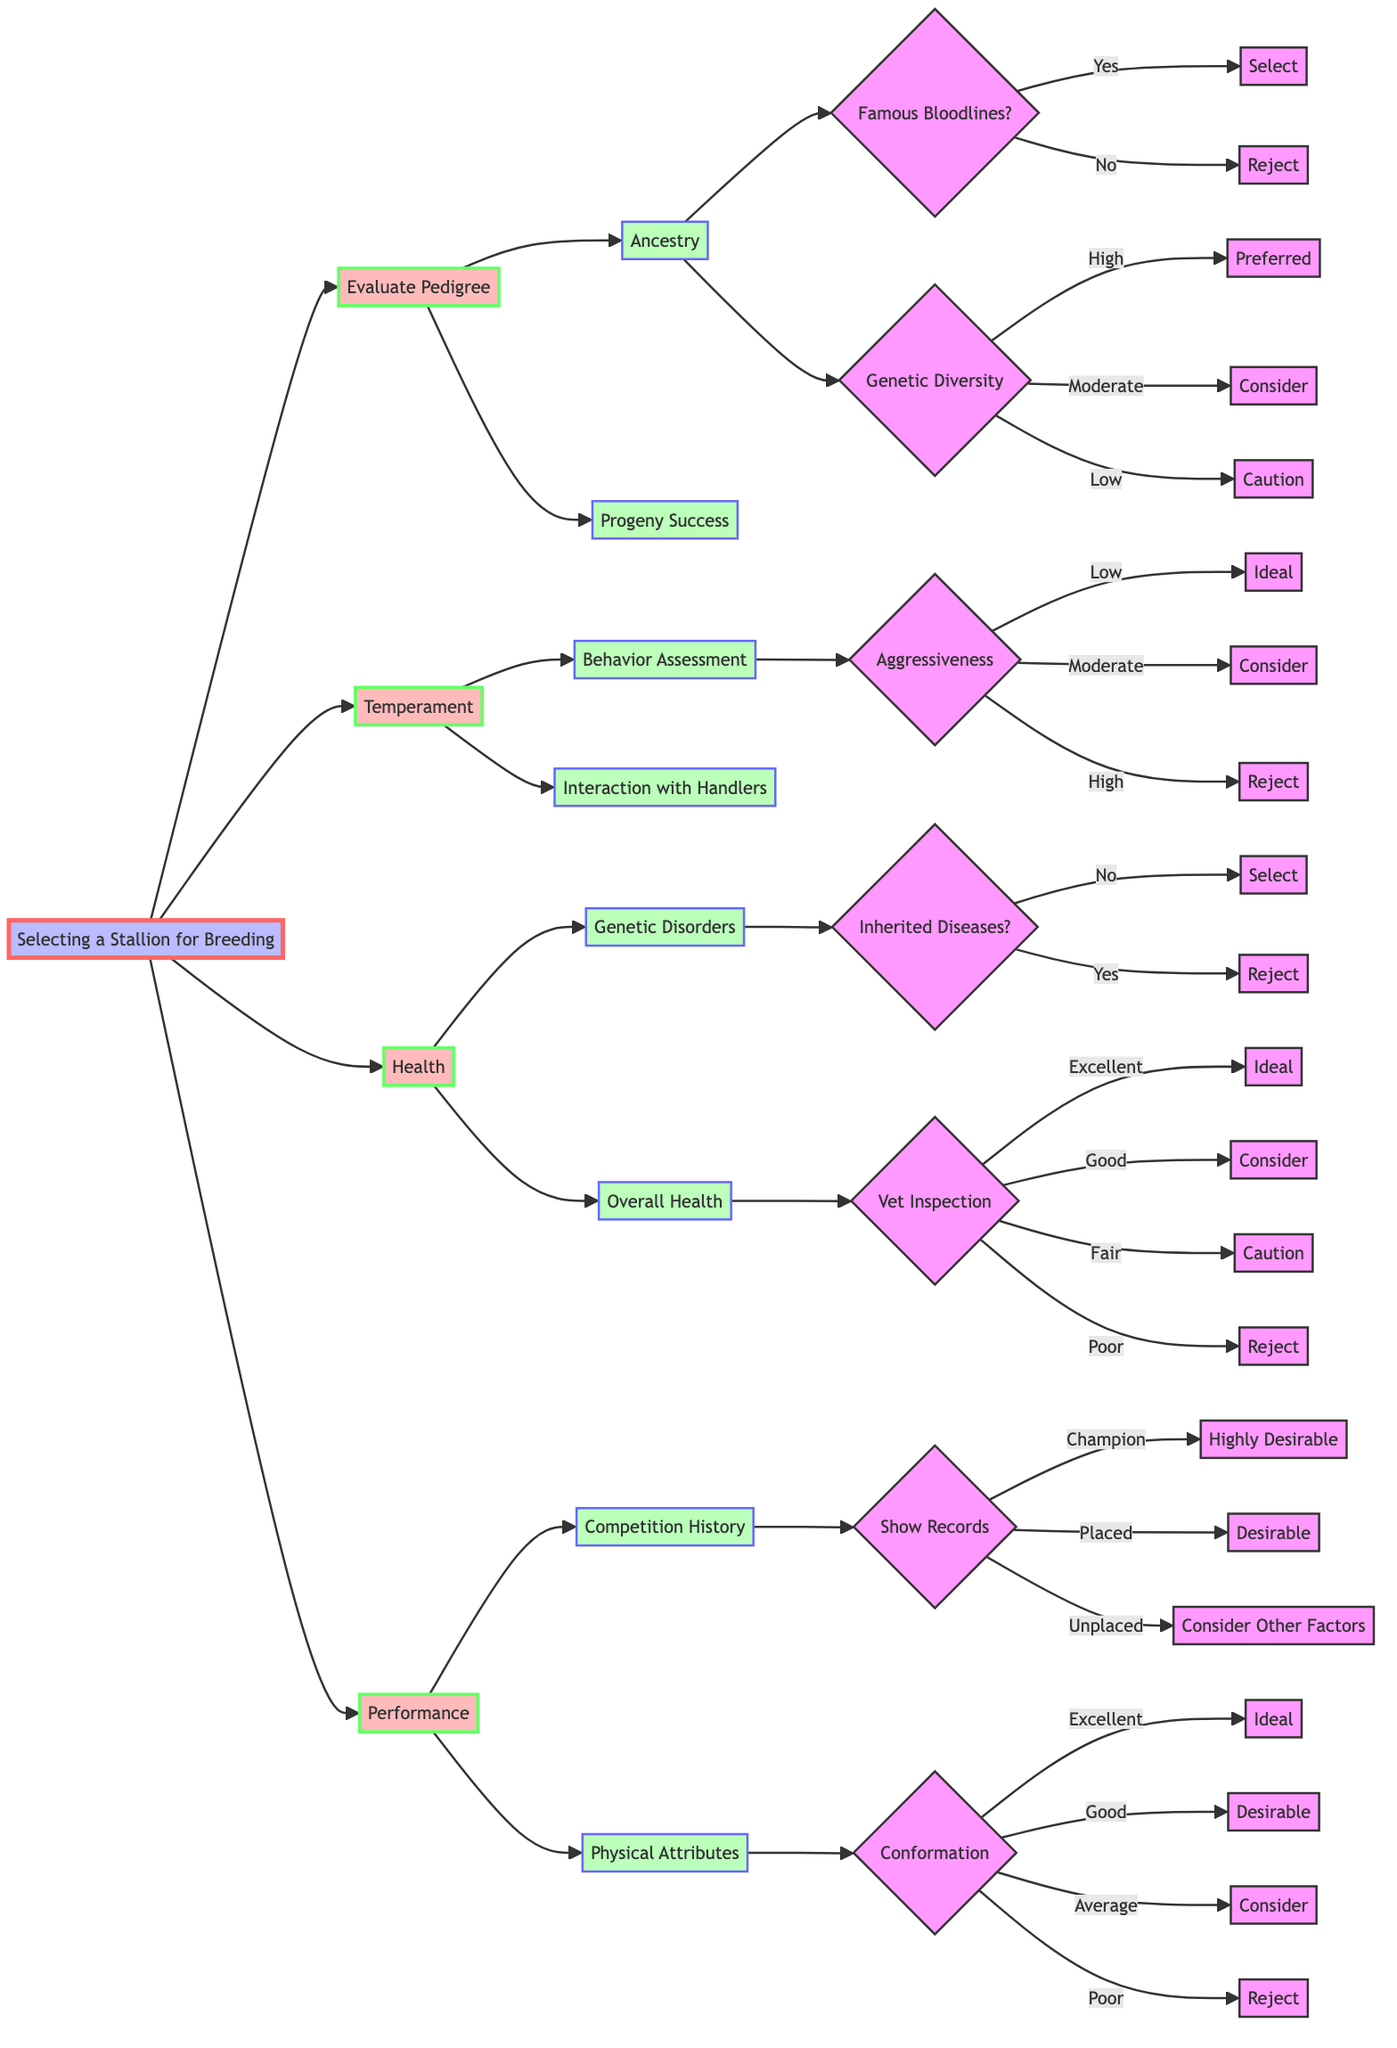What is the first criterion for selecting a stallion? The first level in the diagram lists "Evaluate Pedigree" as the first criterion connected to the main node "Selecting a Stallion for Breeding".
Answer: Evaluate Pedigree How many option categories are there under the "Health" criterion? Looking at the "Health" node, there are two main option categories: "Genetic Disorders" and "Overall Health". Therefore, there are 2 categories.
Answer: 2 What should I do if the stallion has a low score in aggressiveness? If the stallion is assessed with "Low" aggressiveness, the next step indicates "Ideal". This suggests that a low level of aggressiveness is favorable.
Answer: Ideal What happens if a stallion has inherited diseases? The diagram shows that if the stallion has "Inherited Diseases?", the outcome is "Reject". This indicates that the presence of inherited diseases leads to rejection.
Answer: Reject If a stallion's show records indicate he is placed, what action should be taken? According to the decision tree, if the stallion's show records indicate "Placed", the recommendation is to "Desirable". This means this outcome is favorable enough to consider.
Answer: Desirable What are the three levels of genetic diversity in the pedigree evaluation? The "Genetic Diversity" node provides three levels: "High", "Moderate", and "Low". These options allow for categorizing the diversity of the genetic lineage.
Answer: High, Moderate, Low What is the outcome if the stallion's overall health inspection is fair? For the health inspection labeled "Fair", the decision is "Caution". This indicates that a fair health status is not ideal, but caution is warranted.
Answer: Caution What do we select if the stallion has excellent vet inspection results? The decision tree specifies that if the vet inspection results are "Excellent", the action is "Ideal", indicating a strong positive assessment of the stallion's health.
Answer: Ideal What is the recommended action if the stallion has famous bloodlines, but low genetic diversity? With "Yes" for famous bloodlines, we proceed to the genetic diversity node. If it scores "Low", the outcome reflects "Caution". Thus, caution is advised despite famous bloodlines.
Answer: Caution 